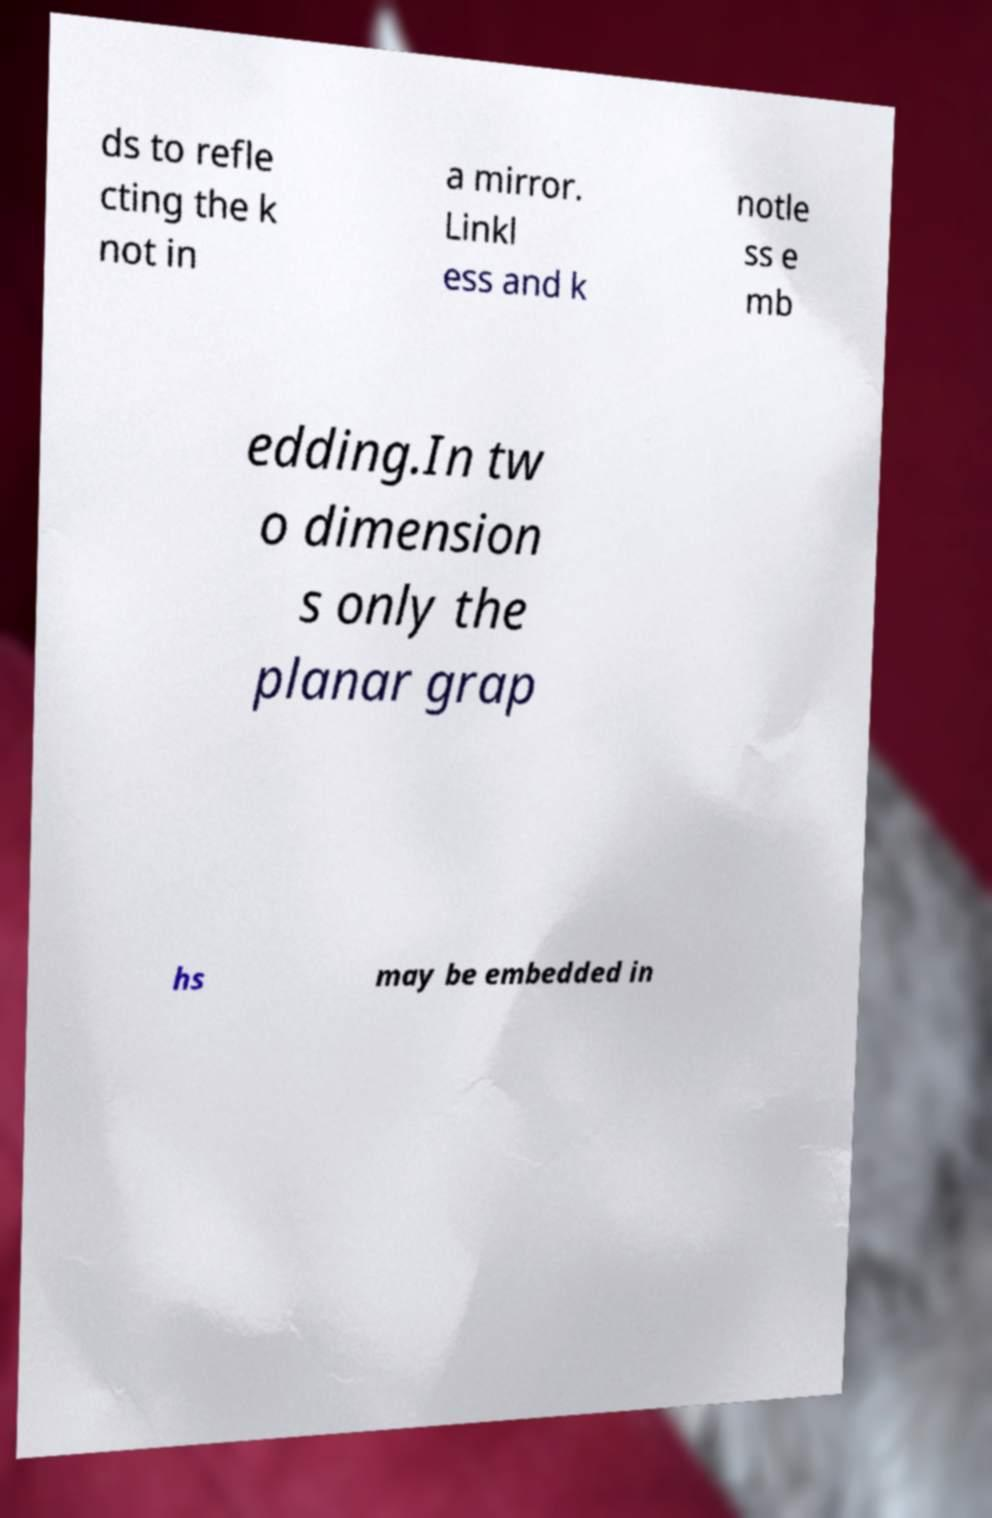There's text embedded in this image that I need extracted. Can you transcribe it verbatim? ds to refle cting the k not in a mirror. Linkl ess and k notle ss e mb edding.In tw o dimension s only the planar grap hs may be embedded in 